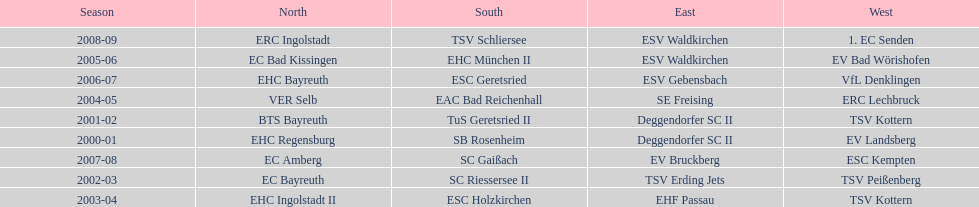Starting with the 2007 - 08 season, does ecs kempten appear in any of the previous years? No. 